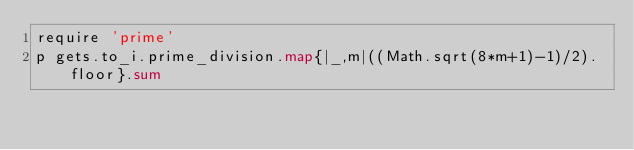<code> <loc_0><loc_0><loc_500><loc_500><_Python_>require 'prime'
p gets.to_i.prime_division.map{|_,m|((Math.sqrt(8*m+1)-1)/2).floor}.sum</code> 